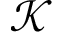Convert formula to latex. <formula><loc_0><loc_0><loc_500><loc_500>\mathcal { K }</formula> 